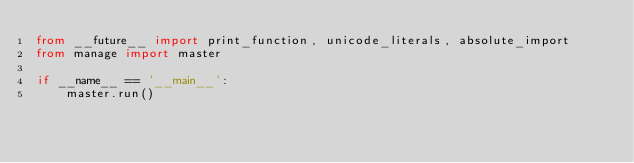Convert code to text. <code><loc_0><loc_0><loc_500><loc_500><_Python_>from __future__ import print_function, unicode_literals, absolute_import
from manage import master

if __name__ == '__main__':
    master.run()
</code> 